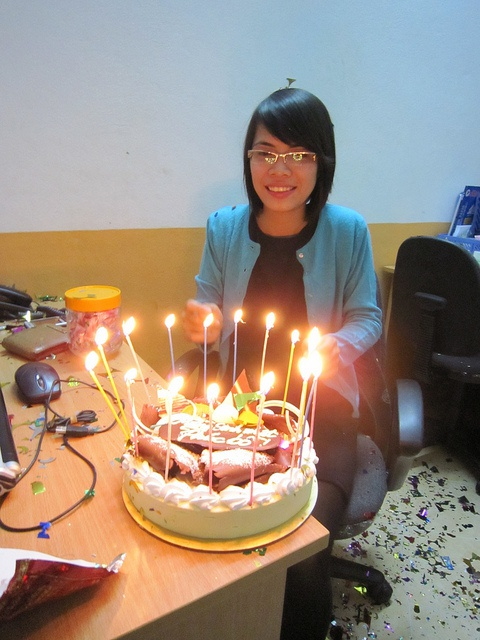Describe the objects in this image and their specific colors. I can see dining table in darkgray, tan, and white tones, people in darkgray, black, gray, brown, and maroon tones, cake in darkgray, white, tan, and salmon tones, chair in darkgray, black, maroon, gray, and brown tones, and chair in darkgray, black, maroon, tan, and gray tones in this image. 